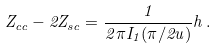Convert formula to latex. <formula><loc_0><loc_0><loc_500><loc_500>Z _ { c c } - 2 Z _ { s c } = \frac { 1 } { 2 \pi I _ { 1 } ( \pi / 2 u ) } h \, .</formula> 